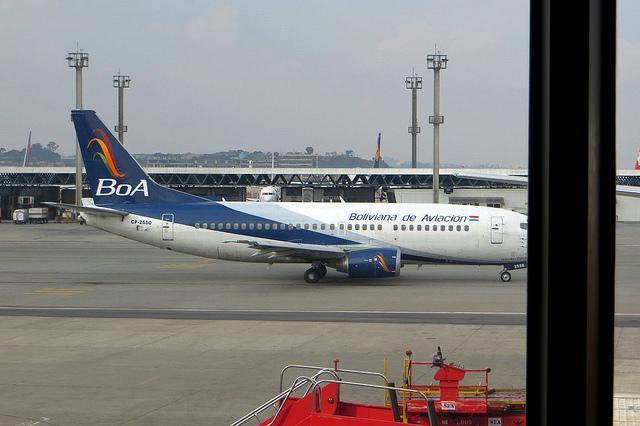How many planes are there?
Give a very brief answer. 1. How many tail fins are in this picture?
Give a very brief answer. 1. 